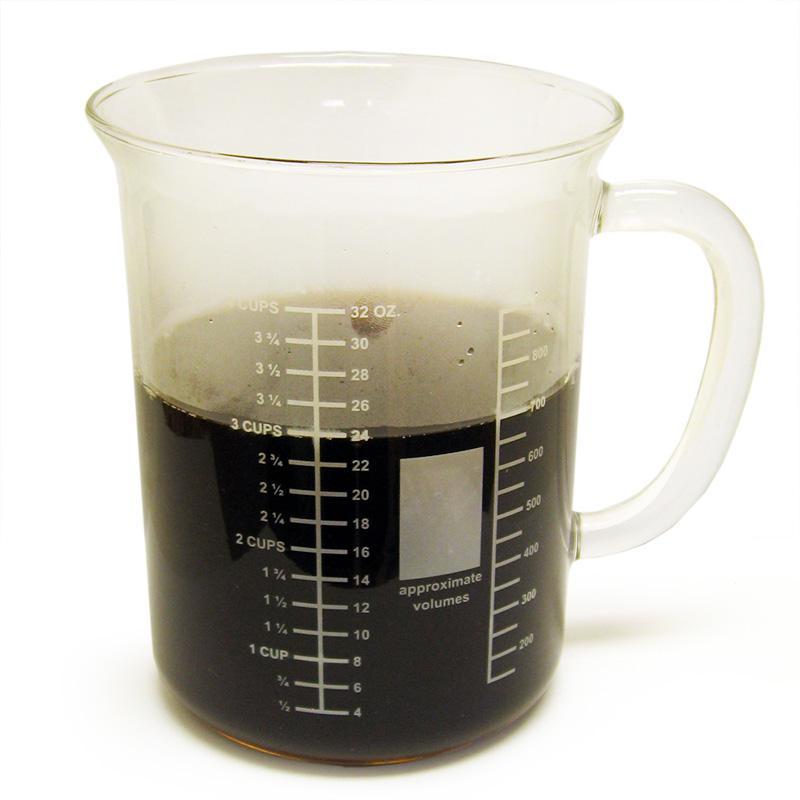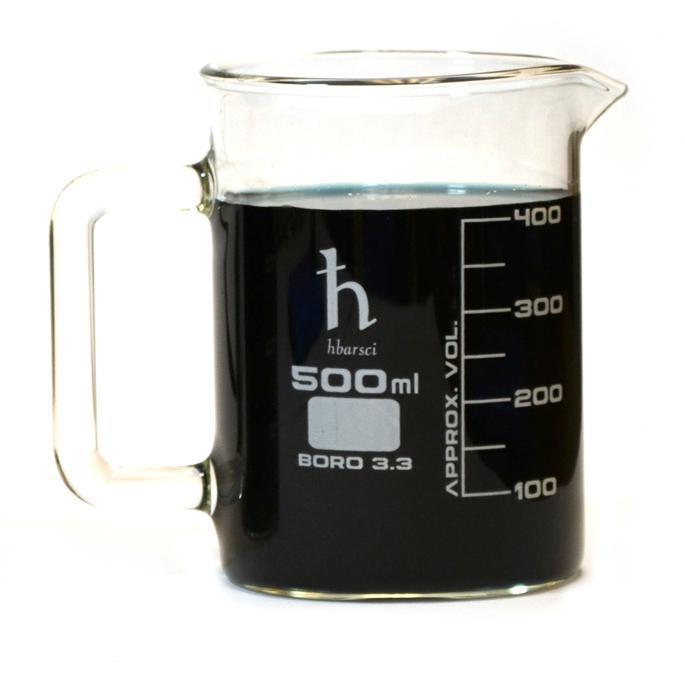The first image is the image on the left, the second image is the image on the right. For the images shown, is this caption "Both beakers are full of coffee." true? Answer yes or no. Yes. The first image is the image on the left, the second image is the image on the right. Examine the images to the left and right. Is the description "The container in each of the images is filled with dark liquid." accurate? Answer yes or no. Yes. 